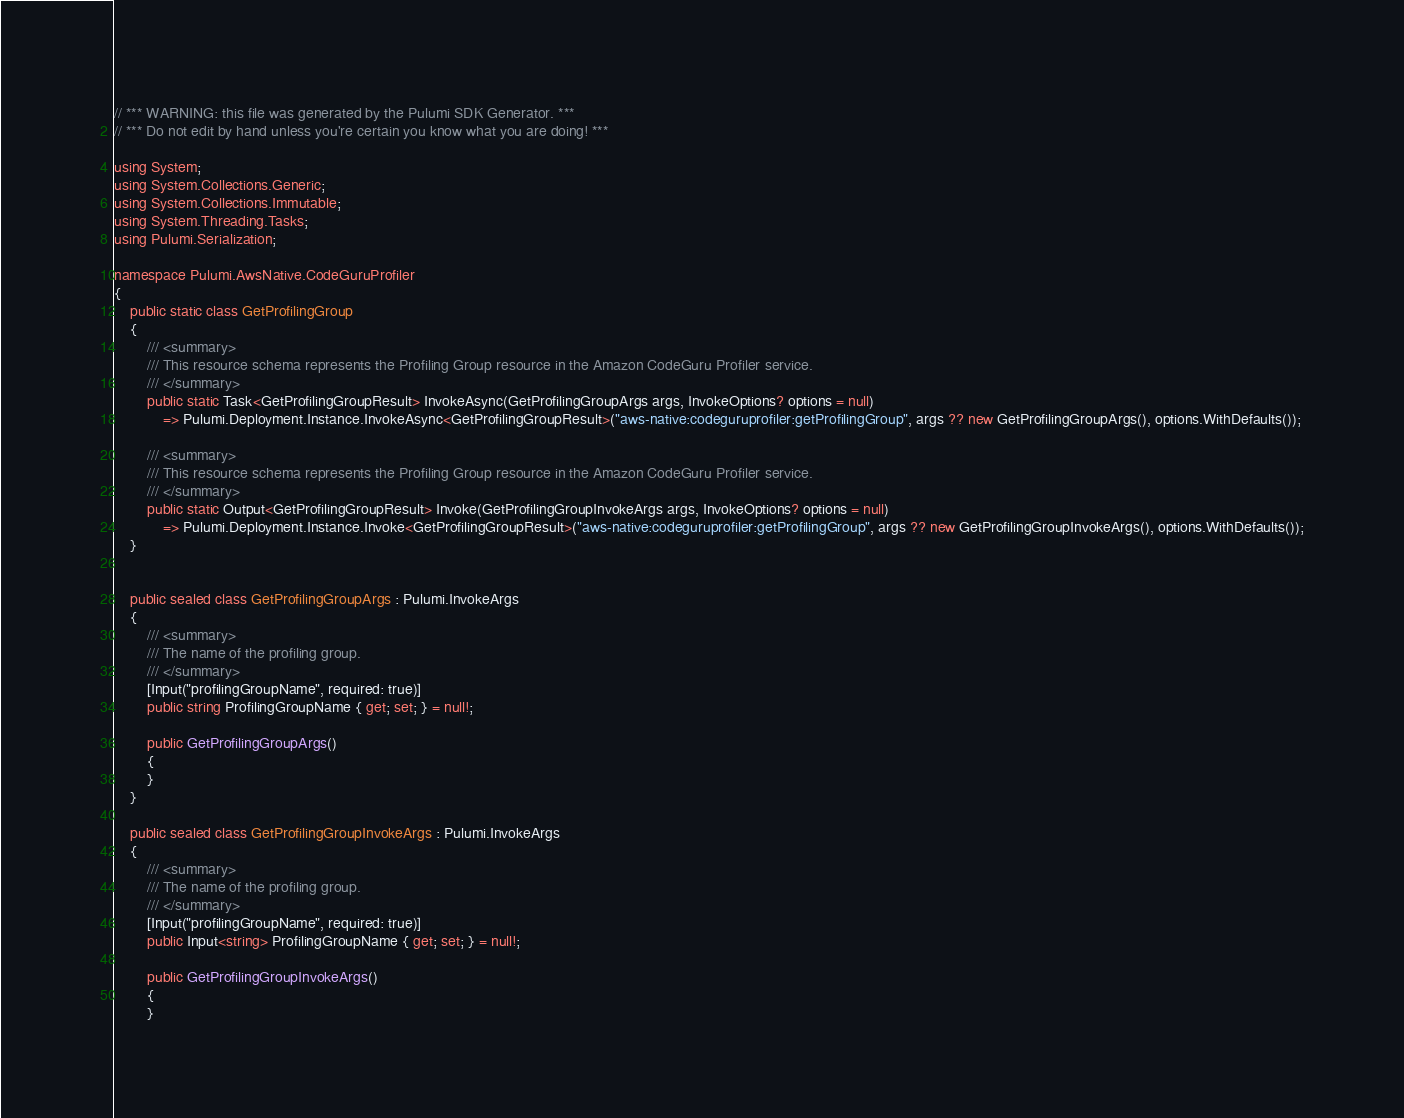Convert code to text. <code><loc_0><loc_0><loc_500><loc_500><_C#_>// *** WARNING: this file was generated by the Pulumi SDK Generator. ***
// *** Do not edit by hand unless you're certain you know what you are doing! ***

using System;
using System.Collections.Generic;
using System.Collections.Immutable;
using System.Threading.Tasks;
using Pulumi.Serialization;

namespace Pulumi.AwsNative.CodeGuruProfiler
{
    public static class GetProfilingGroup
    {
        /// <summary>
        /// This resource schema represents the Profiling Group resource in the Amazon CodeGuru Profiler service.
        /// </summary>
        public static Task<GetProfilingGroupResult> InvokeAsync(GetProfilingGroupArgs args, InvokeOptions? options = null)
            => Pulumi.Deployment.Instance.InvokeAsync<GetProfilingGroupResult>("aws-native:codeguruprofiler:getProfilingGroup", args ?? new GetProfilingGroupArgs(), options.WithDefaults());

        /// <summary>
        /// This resource schema represents the Profiling Group resource in the Amazon CodeGuru Profiler service.
        /// </summary>
        public static Output<GetProfilingGroupResult> Invoke(GetProfilingGroupInvokeArgs args, InvokeOptions? options = null)
            => Pulumi.Deployment.Instance.Invoke<GetProfilingGroupResult>("aws-native:codeguruprofiler:getProfilingGroup", args ?? new GetProfilingGroupInvokeArgs(), options.WithDefaults());
    }


    public sealed class GetProfilingGroupArgs : Pulumi.InvokeArgs
    {
        /// <summary>
        /// The name of the profiling group.
        /// </summary>
        [Input("profilingGroupName", required: true)]
        public string ProfilingGroupName { get; set; } = null!;

        public GetProfilingGroupArgs()
        {
        }
    }

    public sealed class GetProfilingGroupInvokeArgs : Pulumi.InvokeArgs
    {
        /// <summary>
        /// The name of the profiling group.
        /// </summary>
        [Input("profilingGroupName", required: true)]
        public Input<string> ProfilingGroupName { get; set; } = null!;

        public GetProfilingGroupInvokeArgs()
        {
        }</code> 